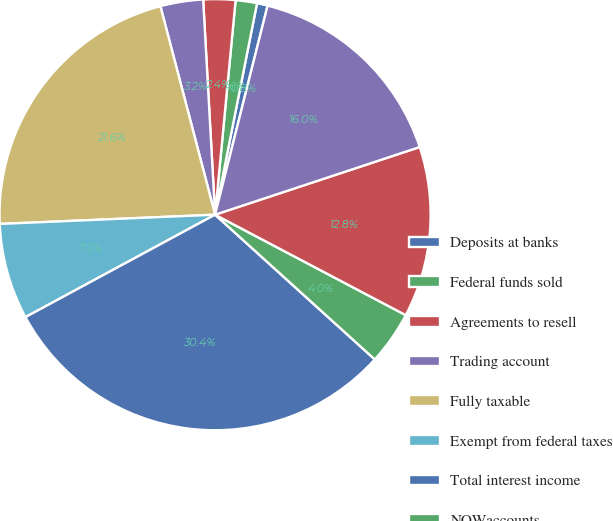Convert chart to OTSL. <chart><loc_0><loc_0><loc_500><loc_500><pie_chart><fcel>Deposits at banks<fcel>Federal funds sold<fcel>Agreements to resell<fcel>Trading account<fcel>Fully taxable<fcel>Exempt from federal taxes<fcel>Total interest income<fcel>NOWaccounts<fcel>Savings deposits<fcel>Time deposits<nl><fcel>0.8%<fcel>1.6%<fcel>2.4%<fcel>3.2%<fcel>21.6%<fcel>7.2%<fcel>30.4%<fcel>4.0%<fcel>12.8%<fcel>16.0%<nl></chart> 